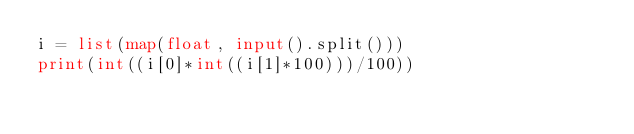<code> <loc_0><loc_0><loc_500><loc_500><_Python_>i = list(map(float, input().split()))
print(int((i[0]*int((i[1]*100)))/100))</code> 